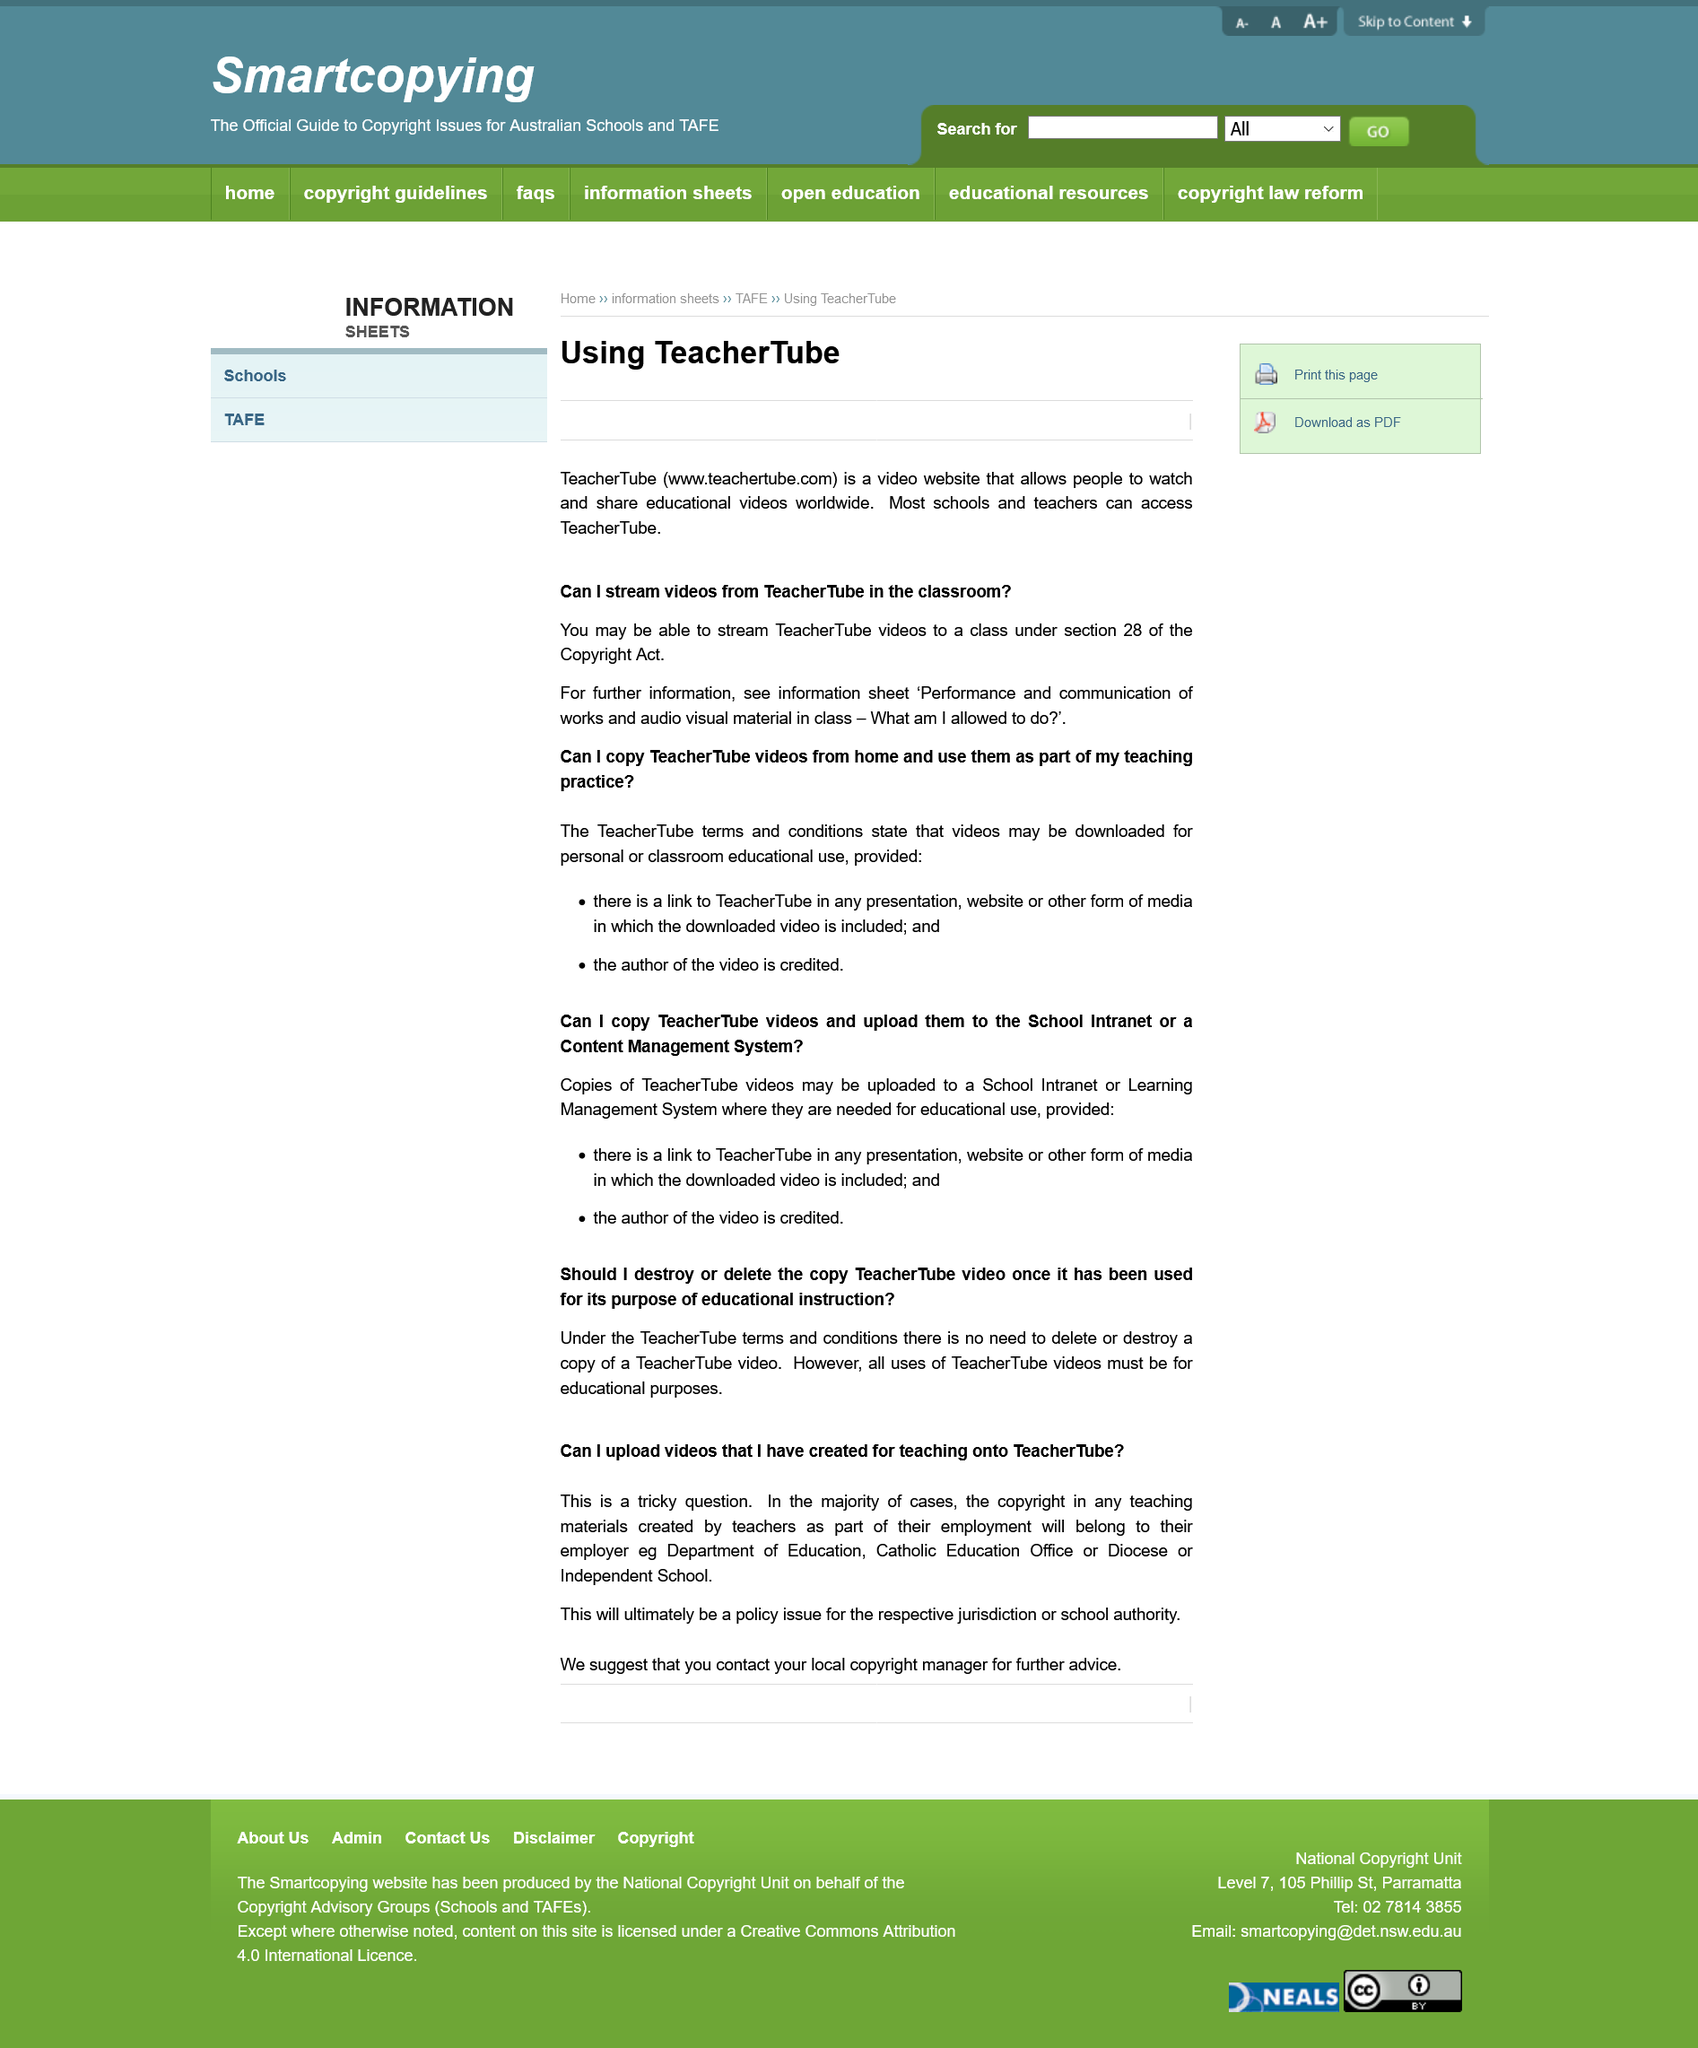Outline some significant characteristics in this image. The Copyright Act allows videos from TeacherTube to be streamed in the classroom, as specified in Section 28. It is not permissible to create copies of TeacherTube videos for personal, non-educational use. TeacherTube is a platform that can be accessed by most schools and teachers. To copy or upload TeacherTube videos to a school intranet, it is necessary to include both a link to TeacherTube and credit to the author of the video. It is false that TeacherTube video copies must be destroyed after educational use is complete. 